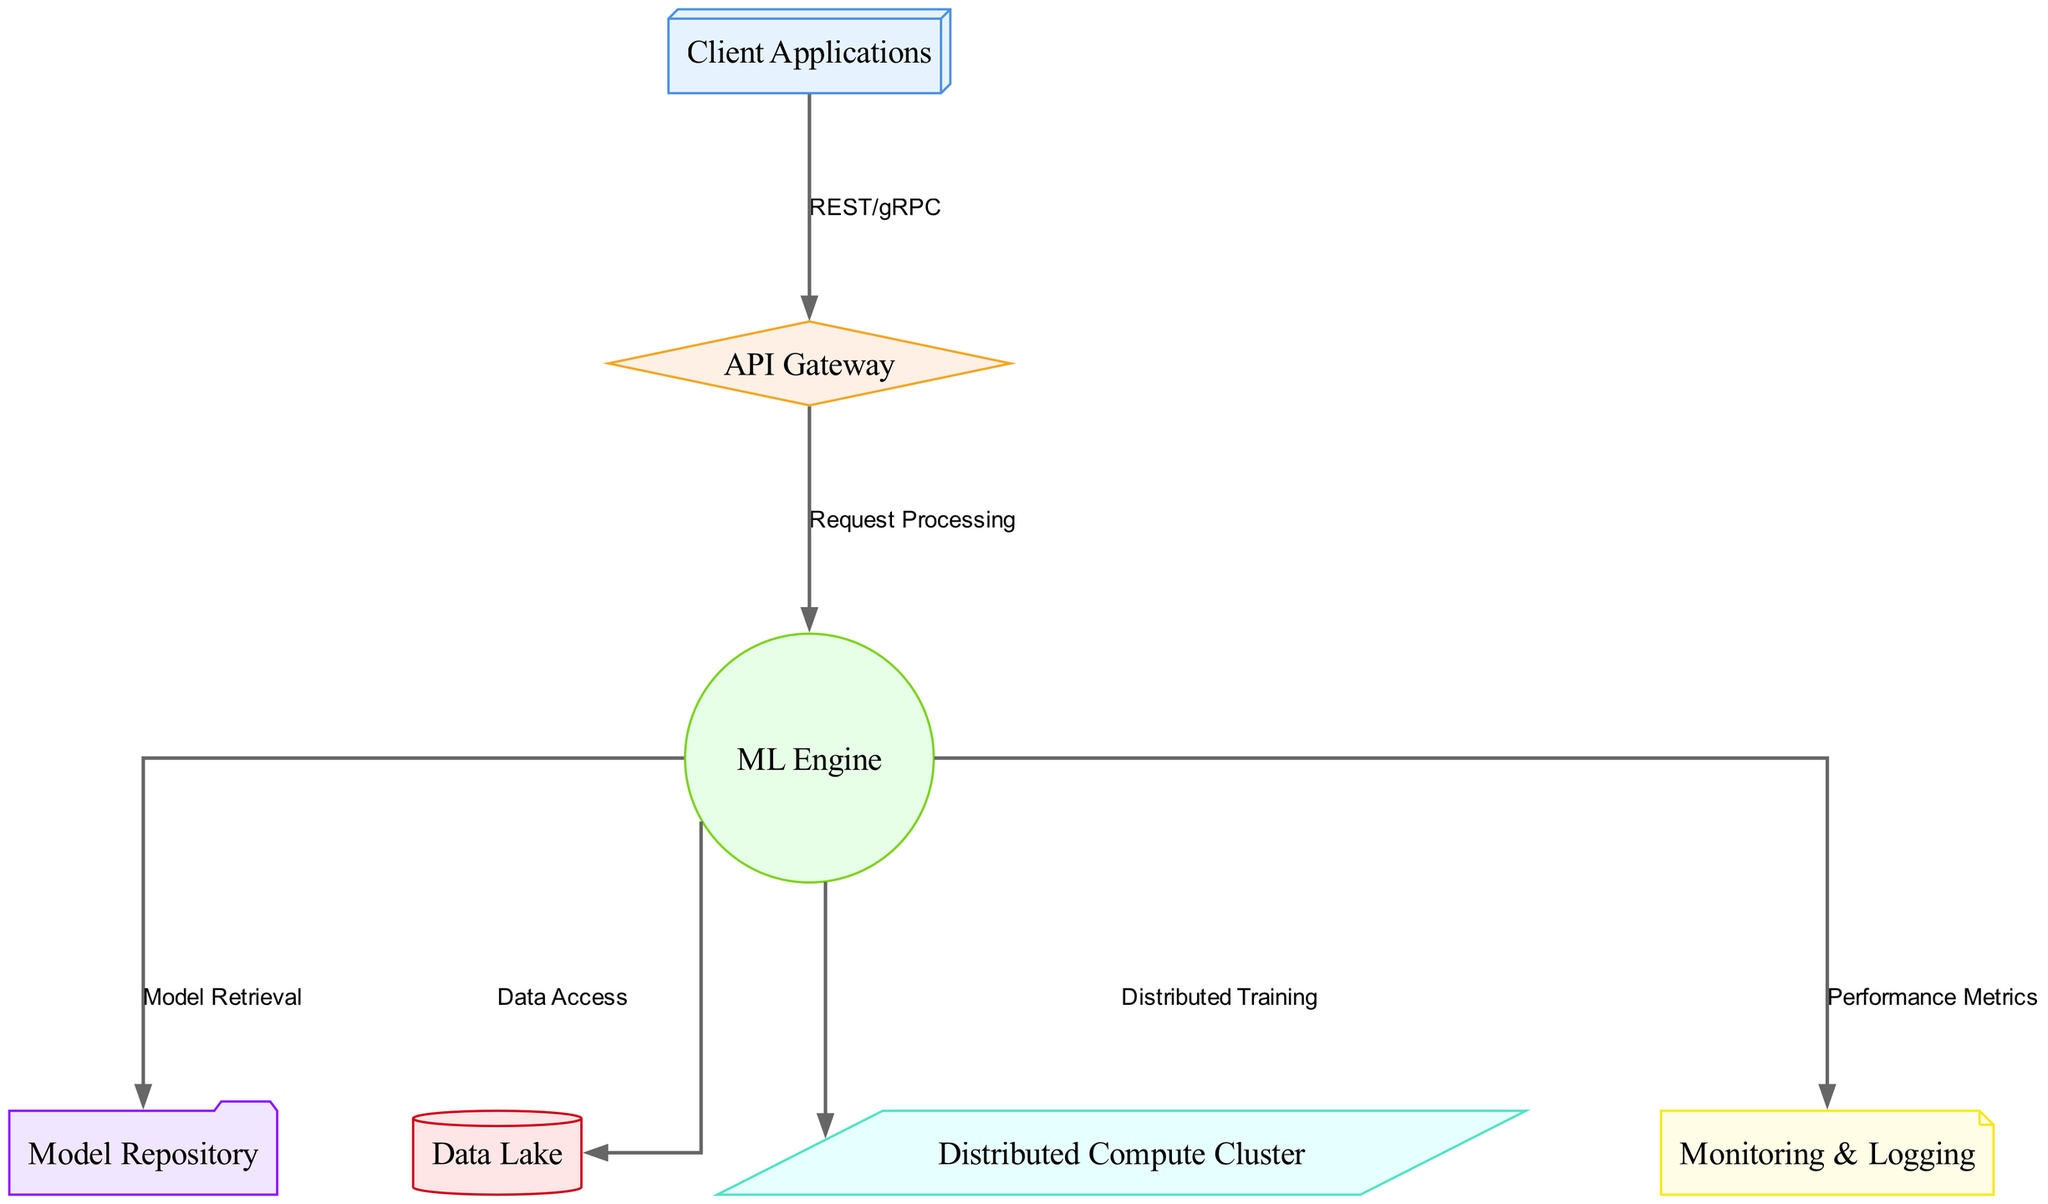What is the label of the node connected to the "Client Applications"? The node connected to "Client Applications" is "API Gateway", which is directly mentioned in the edges of the diagram.
Answer: API Gateway How many nodes are present in this diagram? By counting the unique node entries in the provided data, we find seven nodes: Client Applications, API Gateway, ML Engine, Model Repository, Data Lake, Distributed Compute Cluster, and Monitoring & Logging.
Answer: Seven What is the shape of the "ML Engine" node? The node "ML Engine" is represented as a circle based on the custom styles defined in the diagram generation code.
Answer: Circle Which node does the "ML Engine" retrieve models from? The "ML Engine" retrieves models from the "Model Repository", which is specified in the edge connecting them.
Answer: Model Repository What does the "Distributed Compute Cluster" node signify in this architecture? The "Distributed Compute Cluster" node signifies the component responsible for distributed training as indicated by the edge labeled "Distributed Training" leading from the ML Engine.
Answer: Distributed Training Which technology does the "API Gateway" use to connect with the "Client Applications"? The connection from "Client Applications" to "API Gateway" specifies "REST/gRPC" as the technology used in the edge label between these two nodes.
Answer: REST/gRPC Explain the flow of data from "ML Engine" to "Data Lake". The "ML Engine" accesses the "Data Lake" for data as indicated by the edge labeled "Data Access". The flow begins at the ML Engine, which retrieves and processes the necessary data from the Data Lake for training or evaluation purposes.
Answer: Data Access How many edges are there in the diagram? The diagram has six edges, representing the connections between the various nodes as described in the edges section of the data.
Answer: Six What is the purpose of the "Monitoring & Logging" component? The "Monitoring & Logging" component collects performance metrics from the "ML Engine" to evaluate the performance of the machine learning models, as indicated by the edge labeled "Performance Metrics".
Answer: Performance Metrics 